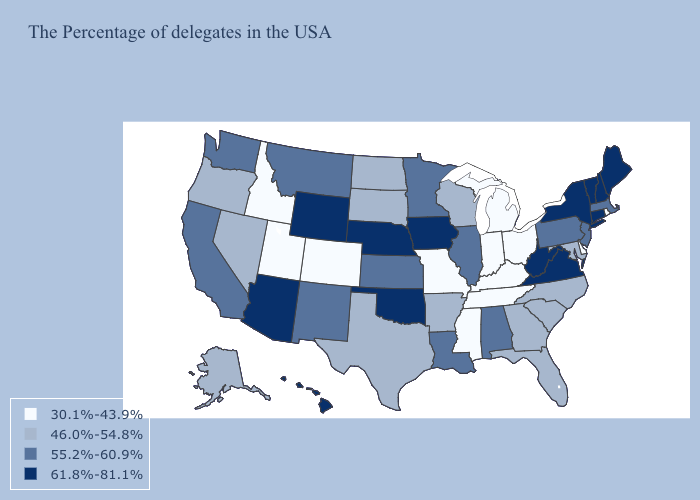What is the value of Rhode Island?
Quick response, please. 30.1%-43.9%. Does New Jersey have the lowest value in the USA?
Quick response, please. No. Does the first symbol in the legend represent the smallest category?
Write a very short answer. Yes. Does Utah have the lowest value in the West?
Give a very brief answer. Yes. Does Oklahoma have the same value as Texas?
Answer briefly. No. What is the lowest value in states that border Mississippi?
Be succinct. 30.1%-43.9%. Name the states that have a value in the range 30.1%-43.9%?
Answer briefly. Rhode Island, Delaware, Ohio, Michigan, Kentucky, Indiana, Tennessee, Mississippi, Missouri, Colorado, Utah, Idaho. What is the value of West Virginia?
Keep it brief. 61.8%-81.1%. Name the states that have a value in the range 55.2%-60.9%?
Quick response, please. Massachusetts, New Jersey, Pennsylvania, Alabama, Illinois, Louisiana, Minnesota, Kansas, New Mexico, Montana, California, Washington. Does Alaska have the lowest value in the USA?
Give a very brief answer. No. Which states have the lowest value in the USA?
Write a very short answer. Rhode Island, Delaware, Ohio, Michigan, Kentucky, Indiana, Tennessee, Mississippi, Missouri, Colorado, Utah, Idaho. What is the value of Illinois?
Quick response, please. 55.2%-60.9%. Name the states that have a value in the range 55.2%-60.9%?
Give a very brief answer. Massachusetts, New Jersey, Pennsylvania, Alabama, Illinois, Louisiana, Minnesota, Kansas, New Mexico, Montana, California, Washington. What is the lowest value in the MidWest?
Short answer required. 30.1%-43.9%. Name the states that have a value in the range 61.8%-81.1%?
Short answer required. Maine, New Hampshire, Vermont, Connecticut, New York, Virginia, West Virginia, Iowa, Nebraska, Oklahoma, Wyoming, Arizona, Hawaii. 